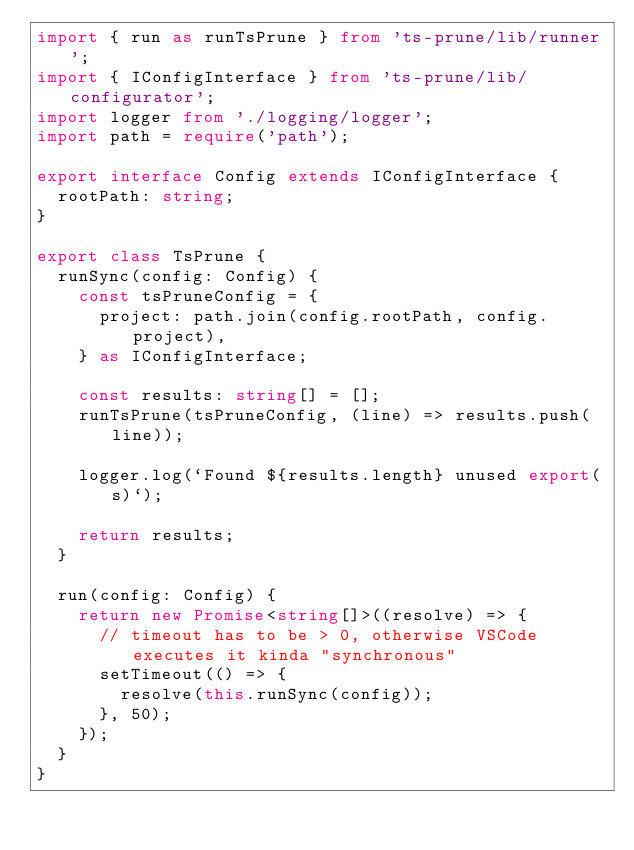<code> <loc_0><loc_0><loc_500><loc_500><_TypeScript_>import { run as runTsPrune } from 'ts-prune/lib/runner';
import { IConfigInterface } from 'ts-prune/lib/configurator';
import logger from './logging/logger';
import path = require('path');

export interface Config extends IConfigInterface {
  rootPath: string;
}

export class TsPrune {
  runSync(config: Config) {
    const tsPruneConfig = {
      project: path.join(config.rootPath, config.project),
    } as IConfigInterface;

    const results: string[] = [];
    runTsPrune(tsPruneConfig, (line) => results.push(line));

    logger.log(`Found ${results.length} unused export(s)`);

    return results;
  }

  run(config: Config) {
    return new Promise<string[]>((resolve) => {
      // timeout has to be > 0, otherwise VSCode executes it kinda "synchronous"
      setTimeout(() => {
        resolve(this.runSync(config));
      }, 50);
    });
  }
}
</code> 